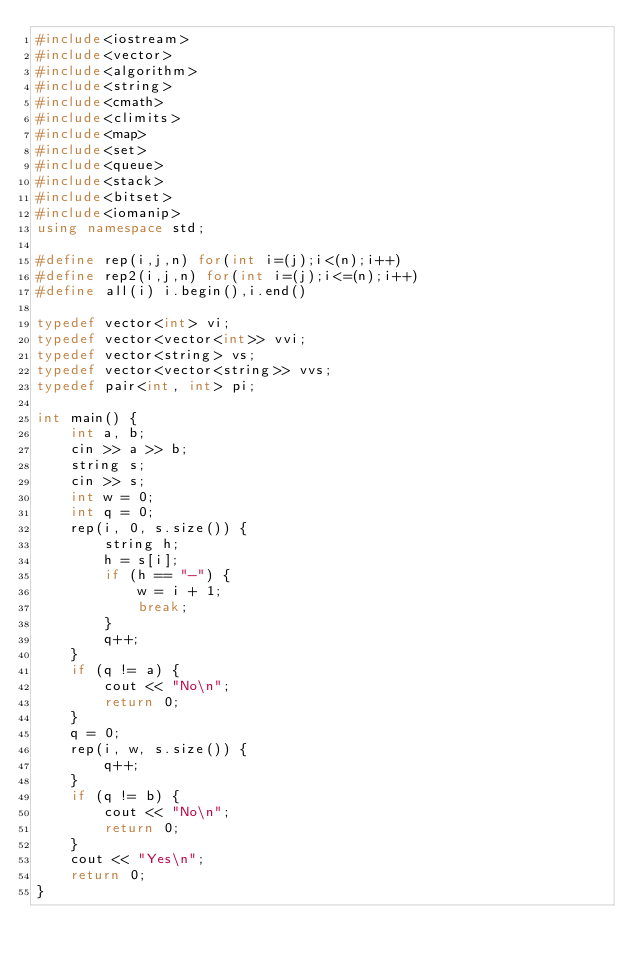<code> <loc_0><loc_0><loc_500><loc_500><_C++_>#include<iostream>
#include<vector>
#include<algorithm>
#include<string>
#include<cmath>
#include<climits>
#include<map>
#include<set>
#include<queue>
#include<stack>
#include<bitset>
#include<iomanip>
using namespace std;

#define rep(i,j,n) for(int i=(j);i<(n);i++)
#define rep2(i,j,n) for(int i=(j);i<=(n);i++)
#define all(i) i.begin(),i.end()

typedef vector<int> vi;
typedef vector<vector<int>> vvi;
typedef vector<string> vs;
typedef vector<vector<string>> vvs;
typedef pair<int, int> pi;

int main() {
	int a, b;
	cin >> a >> b;
	string s;
	cin >> s;
	int w = 0;
	int q = 0;
	rep(i, 0, s.size()) {
		string h;
		h = s[i];
		if (h == "-") {
			w = i + 1;
			break;
		}
		q++;
	}
	if (q != a) {
		cout << "No\n";
		return 0;
	}
	q = 0;
	rep(i, w, s.size()) {
		q++;
	}
	if (q != b) {
		cout << "No\n";
		return 0;
	}
	cout << "Yes\n";
	return 0;
}</code> 